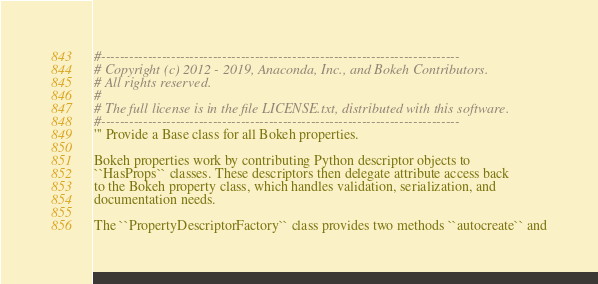Convert code to text. <code><loc_0><loc_0><loc_500><loc_500><_Python_>#-----------------------------------------------------------------------------
# Copyright (c) 2012 - 2019, Anaconda, Inc., and Bokeh Contributors.
# All rights reserved.
#
# The full license is in the file LICENSE.txt, distributed with this software.
#-----------------------------------------------------------------------------
''' Provide a Base class for all Bokeh properties.

Bokeh properties work by contributing Python descriptor objects to
``HasProps`` classes. These descriptors then delegate attribute access back
to the Bokeh property class, which handles validation, serialization, and
documentation needs.

The ``PropertyDescriptorFactory`` class provides two methods ``autocreate`` and</code> 